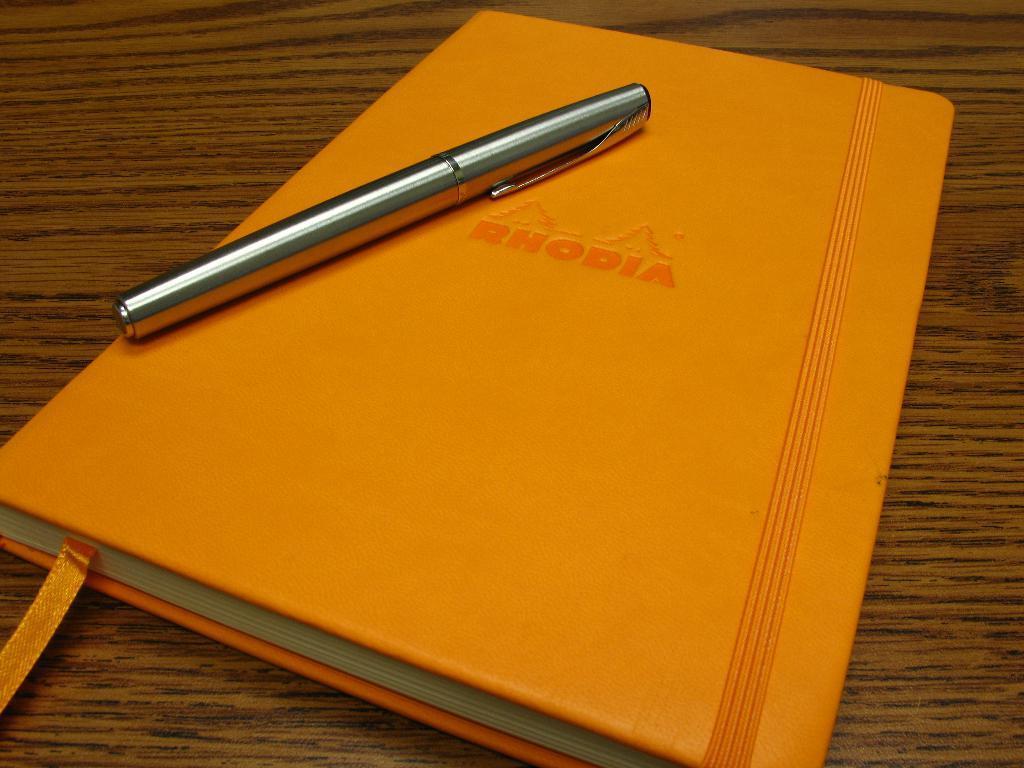Could you give a brief overview of what you see in this image? Here we can see a book and a pen on the wooden platform. 